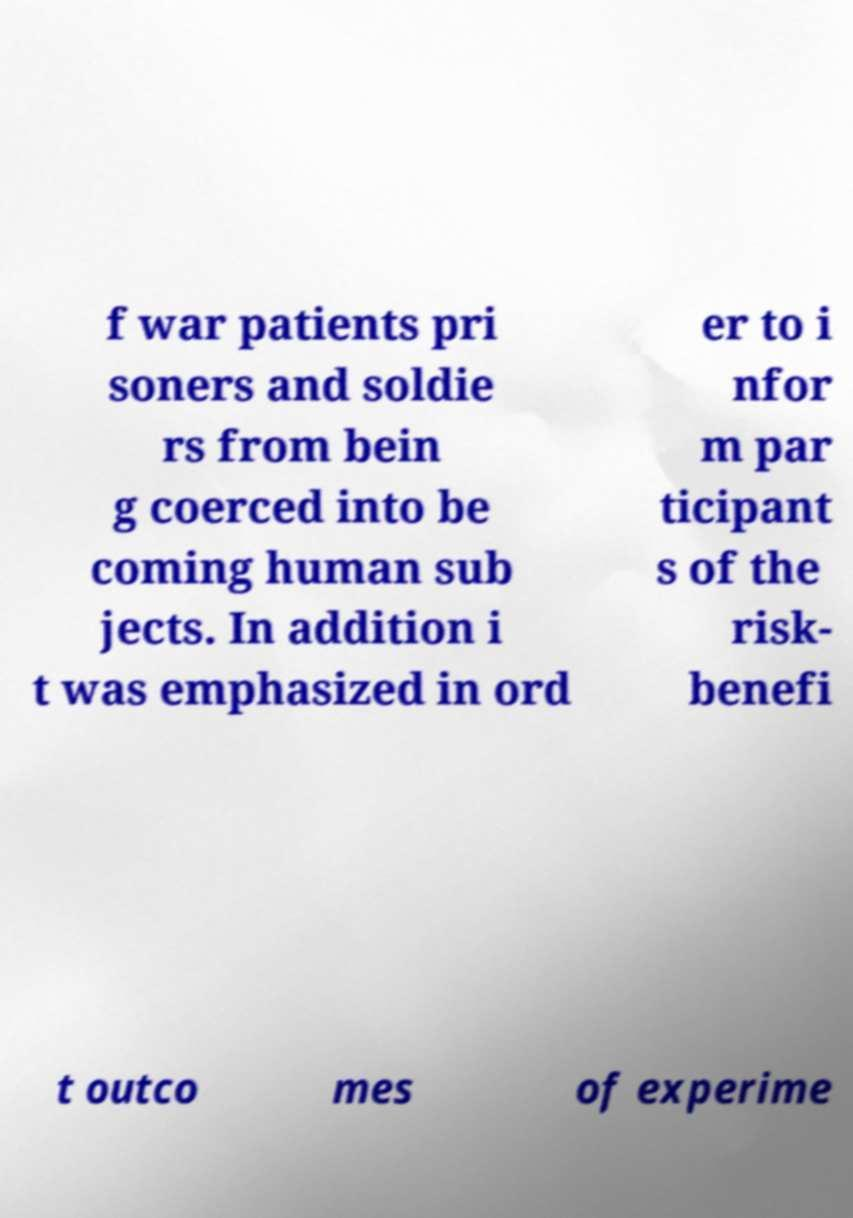Could you extract and type out the text from this image? f war patients pri soners and soldie rs from bein g coerced into be coming human sub jects. In addition i t was emphasized in ord er to i nfor m par ticipant s of the risk- benefi t outco mes of experime 